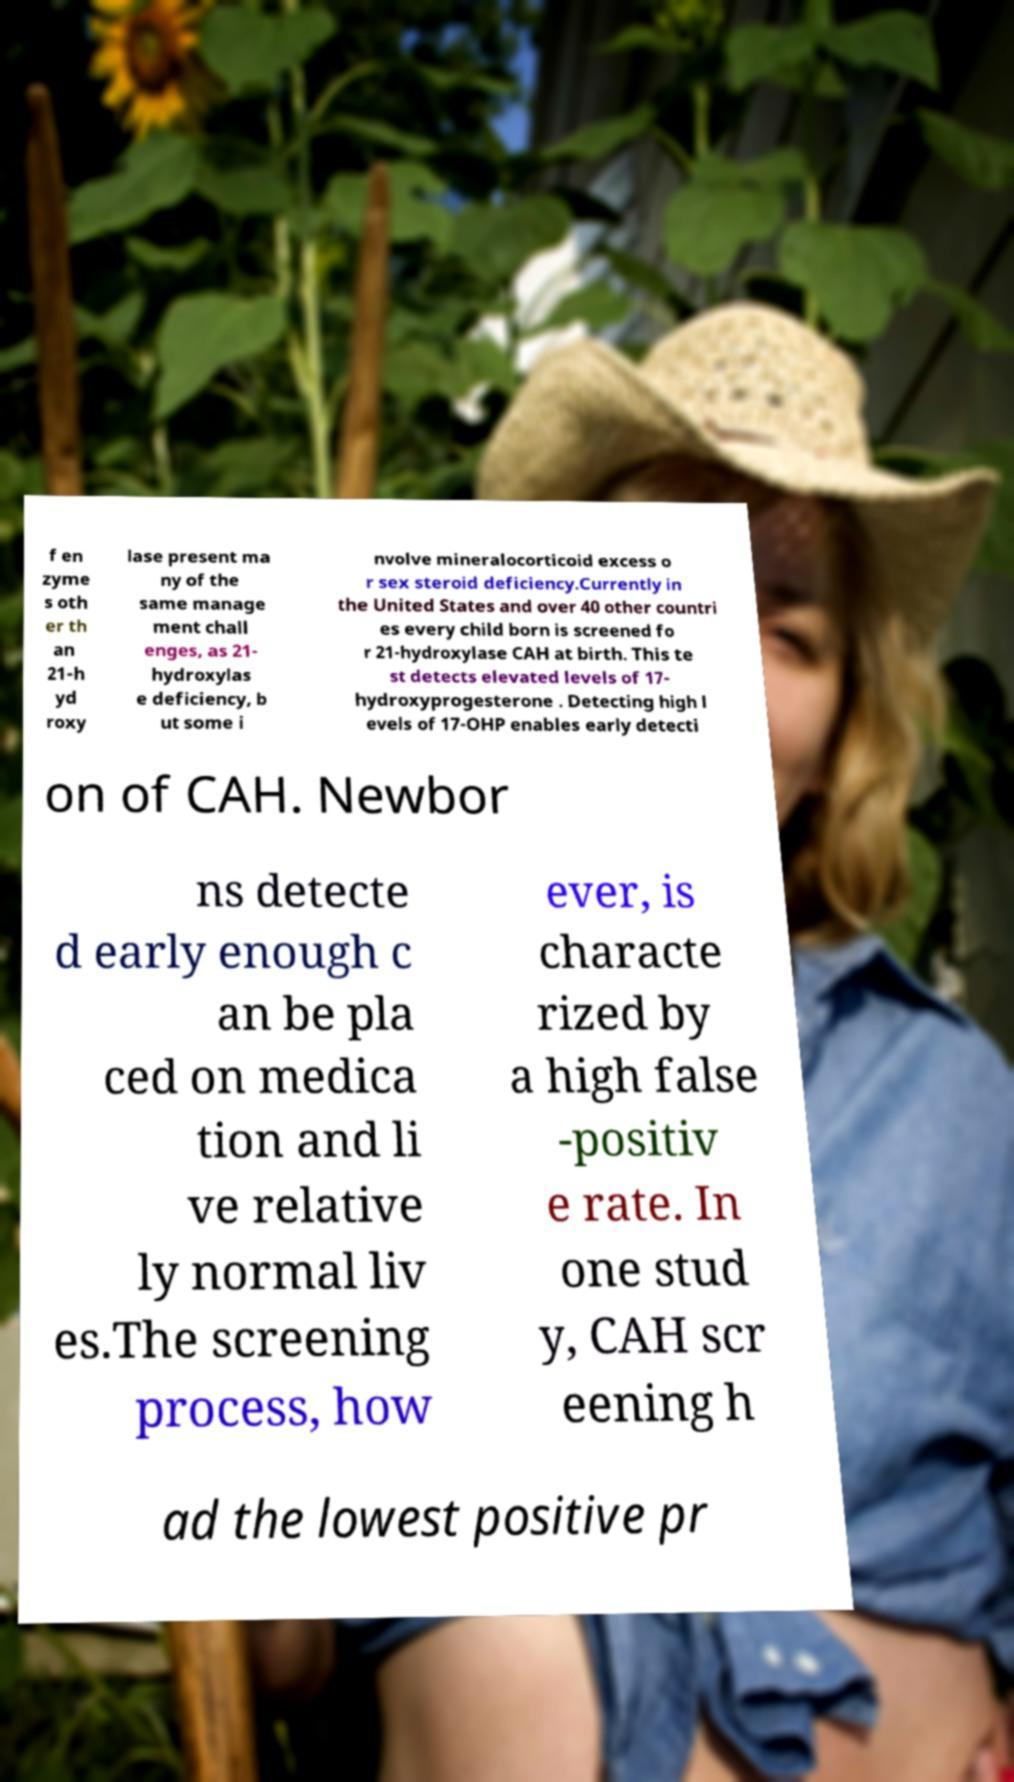Could you assist in decoding the text presented in this image and type it out clearly? f en zyme s oth er th an 21-h yd roxy lase present ma ny of the same manage ment chall enges, as 21- hydroxylas e deficiency, b ut some i nvolve mineralocorticoid excess o r sex steroid deficiency.Currently in the United States and over 40 other countri es every child born is screened fo r 21-hydroxylase CAH at birth. This te st detects elevated levels of 17- hydroxyprogesterone . Detecting high l evels of 17-OHP enables early detecti on of CAH. Newbor ns detecte d early enough c an be pla ced on medica tion and li ve relative ly normal liv es.The screening process, how ever, is characte rized by a high false -positiv e rate. In one stud y, CAH scr eening h ad the lowest positive pr 